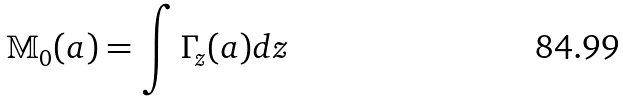Convert formula to latex. <formula><loc_0><loc_0><loc_500><loc_500>\mathbb { M } _ { 0 } ( a ) = \int \Gamma _ { z } ( a ) d z</formula> 